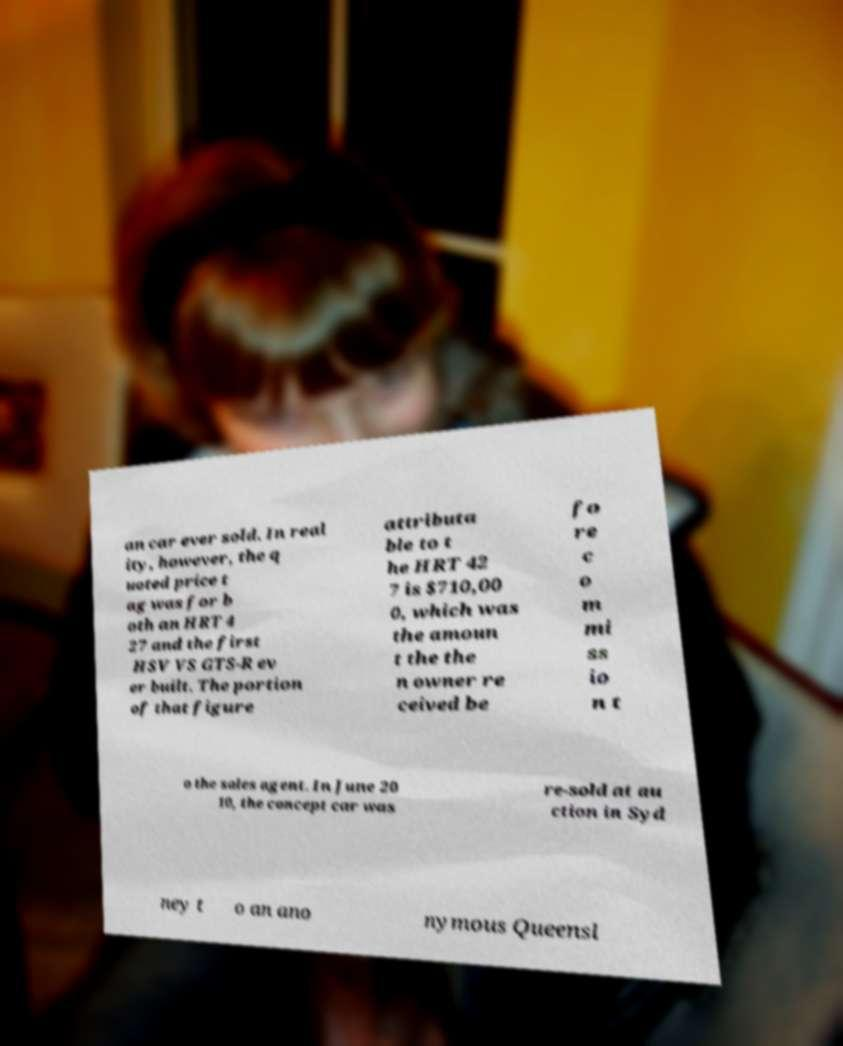Please read and relay the text visible in this image. What does it say? an car ever sold. In real ity, however, the q uoted price t ag was for b oth an HRT 4 27 and the first HSV VS GTS-R ev er built. The portion of that figure attributa ble to t he HRT 42 7 is $710,00 0, which was the amoun t the the n owner re ceived be fo re c o m mi ss io n t o the sales agent. In June 20 10, the concept car was re-sold at au ction in Syd ney t o an ano nymous Queensl 